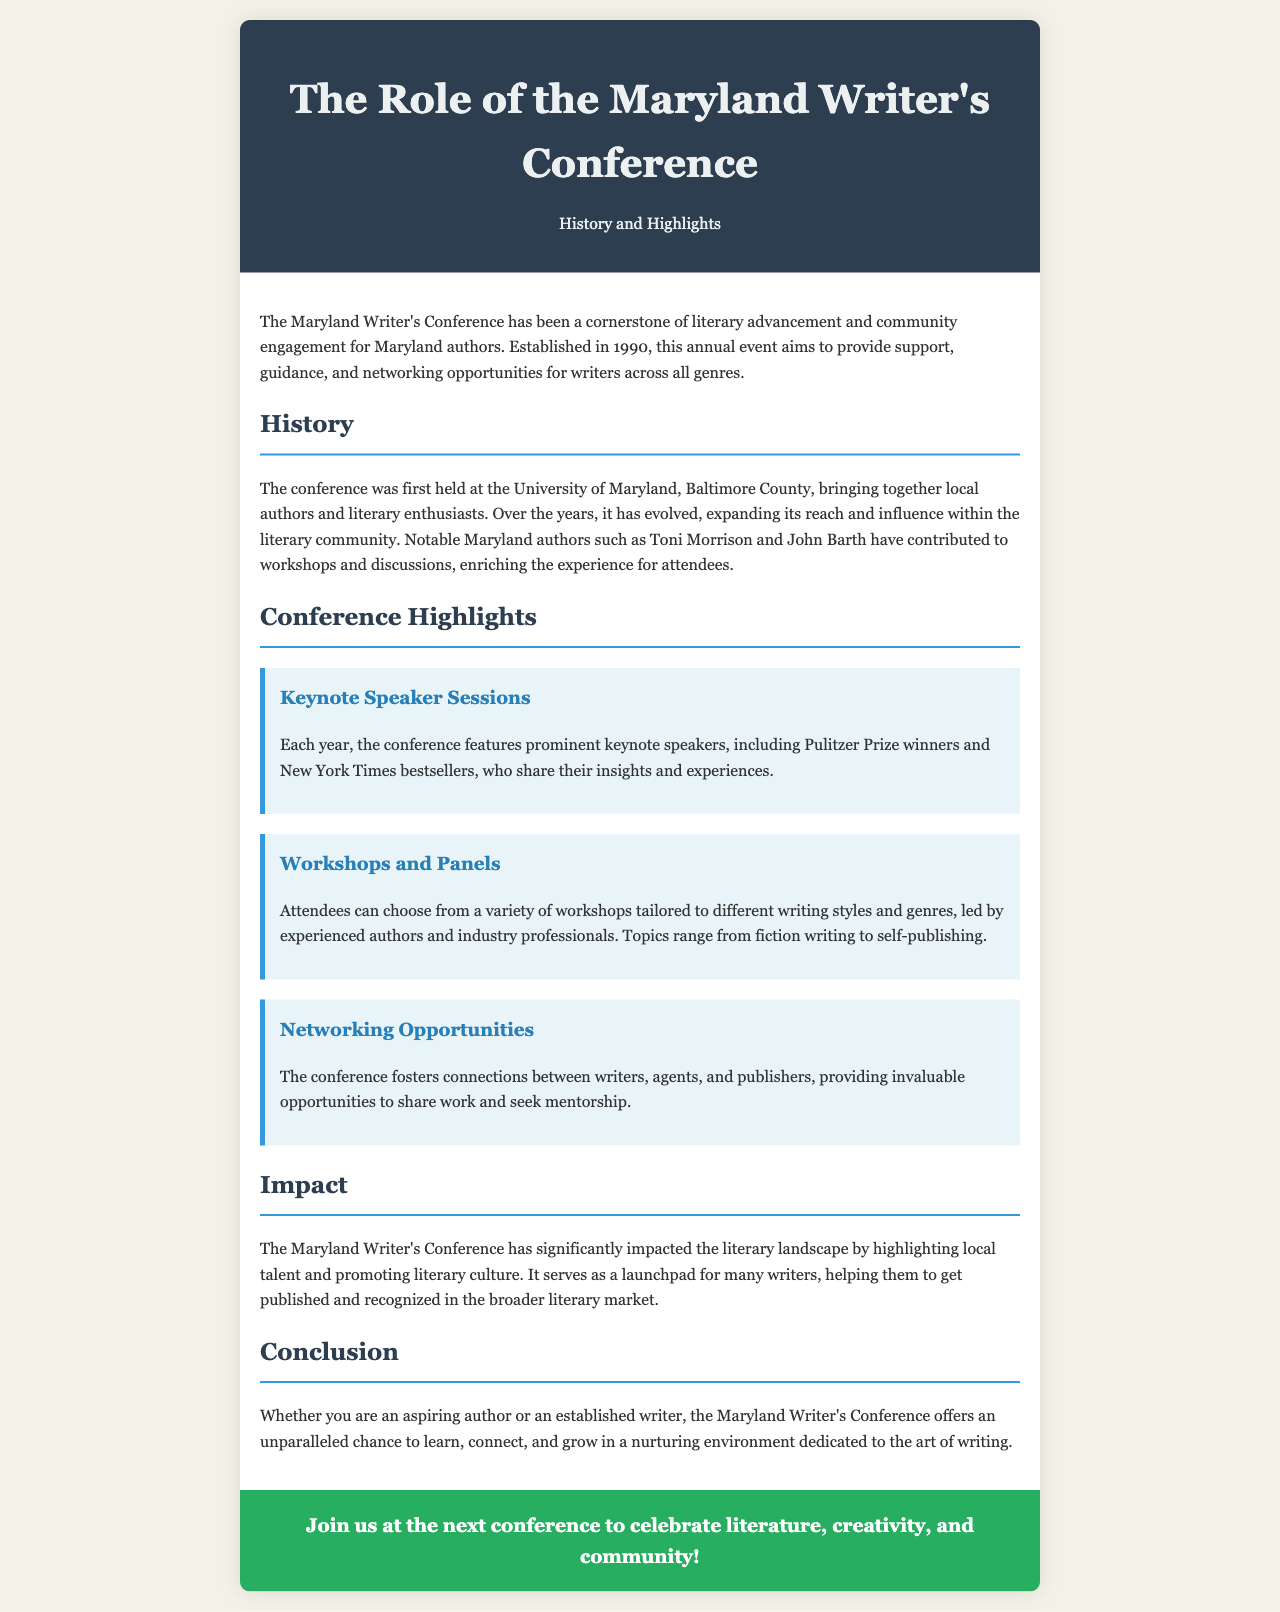What year was the Maryland Writer's Conference established? The establishment year is stated in the introduction of the document, which is 1990.
Answer: 1990 Where was the first Maryland Writer's Conference held? The location of the first conference is mentioned in the history section, which is the University of Maryland, Baltimore County.
Answer: University of Maryland, Baltimore County Who are two notable authors mentioned in the brochure? The document lists notable authors who have contributed, specifically Toni Morrison and John Barth.
Answer: Toni Morrison, John Barth What types of writing topics are covered in the workshops? The document specifies various topics for workshops, such as fiction writing and self-publishing.
Answer: Fiction writing, self-publishing What is highlighted as a benefit of attending the conference? The brochure emphasizes networking opportunities as a significant advantage for attendees.
Answer: Networking Opportunities How many types of conference highlights are listed? The document categorizes the highlights into three specific types, indicating the number of highlights mentioned.
Answer: Three What does the conclusion suggest about the Maryland Writer's Conference? The conclusion highlights the conference as a place for both aspiring and established writers to learn and connect.
Answer: Learn, connect, and grow What color is used for the CTA section of the brochure? The document describes the color for the CTA section as green, referring to its background design.
Answer: Green 